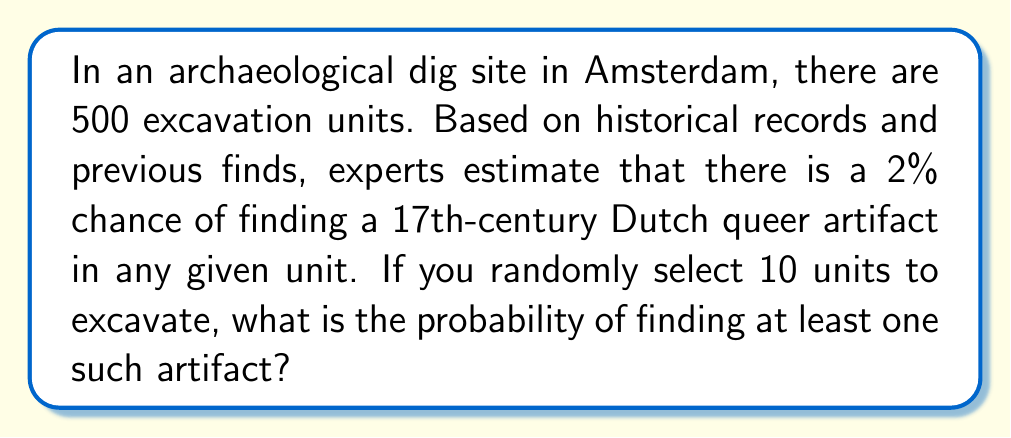Give your solution to this math problem. Let's approach this step-by-step using the binomial probability distribution:

1) First, let's define our variables:
   $p = 0.02$ (probability of success in one trial)
   $n = 10$ (number of trials)

2) We want to find the probability of at least one success, which is the complement of the probability of no successes:

   $P(\text{at least one}) = 1 - P(\text{none})$

3) The probability of no successes in 10 trials is:

   $P(\text{none}) = (1-p)^n = (0.98)^{10}$

4) Now we can calculate:

   $P(\text{at least one}) = 1 - (0.98)^{10}$

5) Using a calculator or computer:

   $(0.98)^{10} \approx 0.8179$

6) Therefore:

   $P(\text{at least one}) = 1 - 0.8179 \approx 0.1821$

7) Convert to a percentage:

   $0.1821 \times 100\% = 18.21\%$

This means there's approximately an 18.21% chance of finding at least one 17th-century Dutch queer artifact in 10 randomly selected excavation units.
Answer: 18.21% 